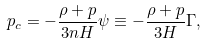Convert formula to latex. <formula><loc_0><loc_0><loc_500><loc_500>p _ { c } = - \frac { \rho + p } { 3 n H } \psi \equiv - \frac { \rho + p } { 3 H } \Gamma ,</formula> 